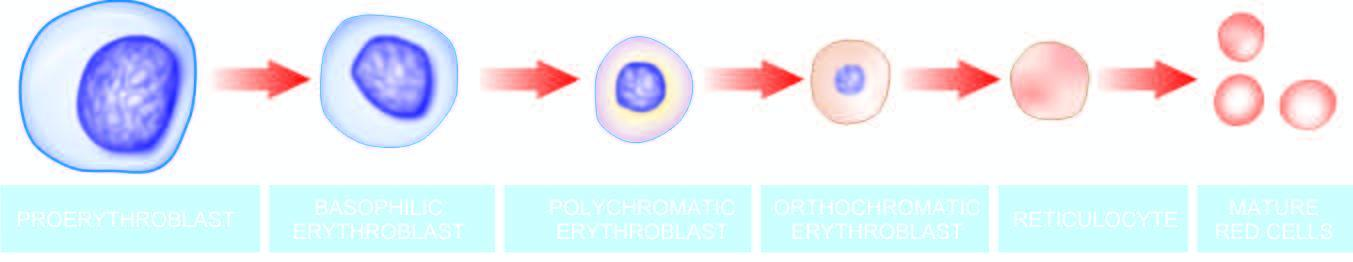what contains progressively less rna and more haemoglobin?
Answer the question using a single word or phrase. The cytoplasm 